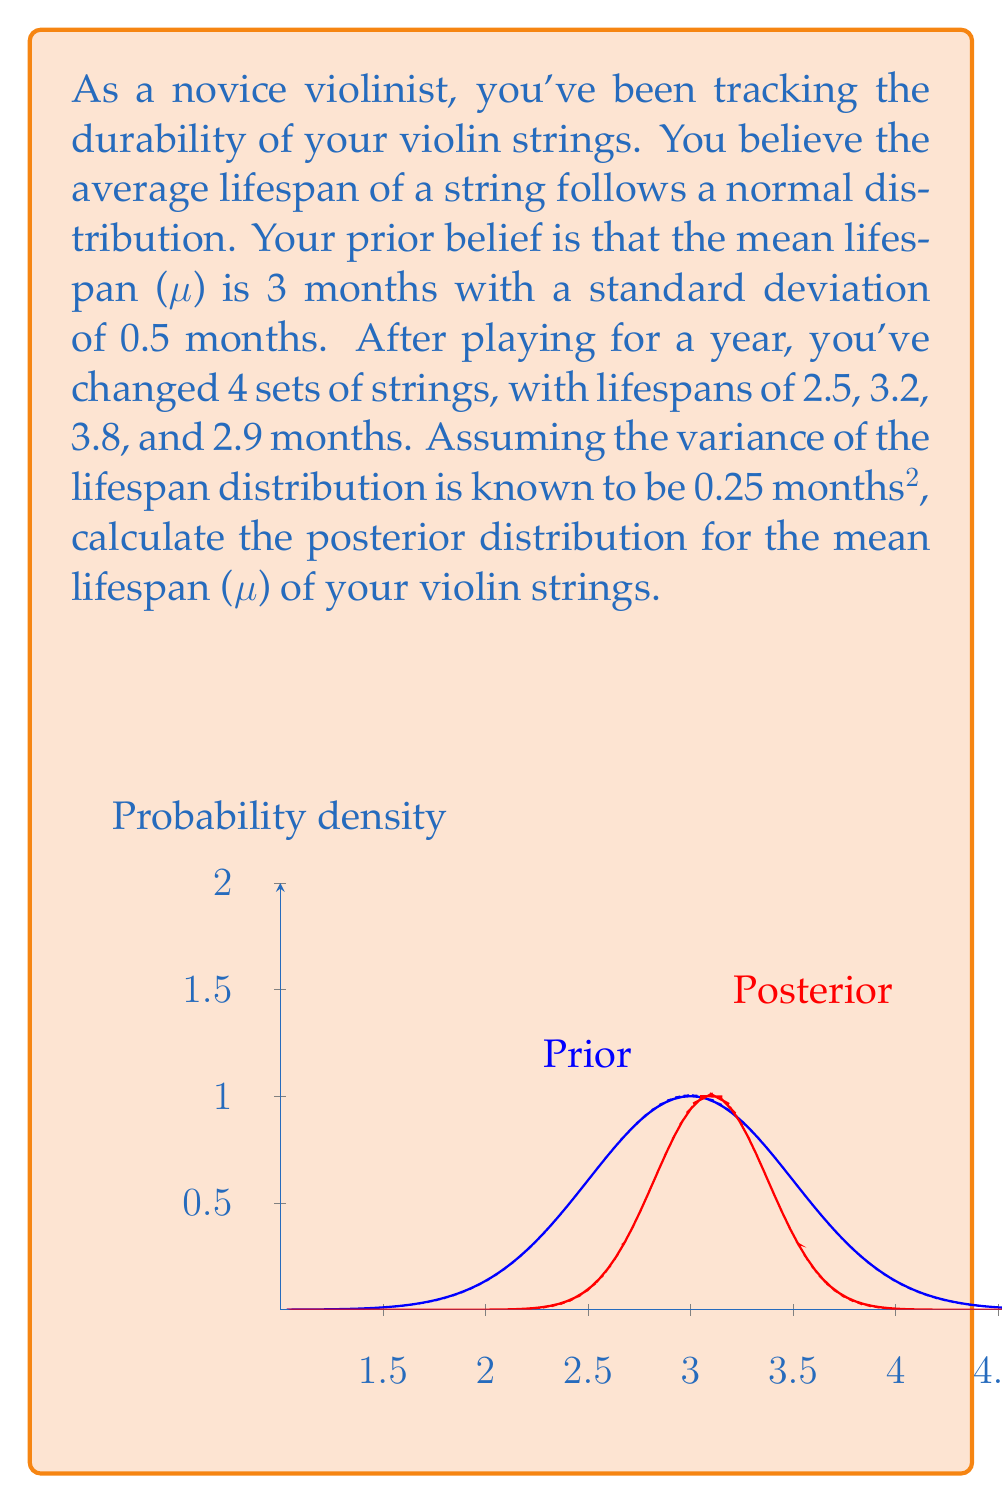Can you solve this math problem? Let's approach this step-by-step using Bayesian inference:

1) Prior distribution:
   $\mu \sim N(3, 0.5^2)$

2) Likelihood:
   The likelihood is based on our observed data. With 4 observations and known variance:
   $X_i \sim N(\mu, 0.25)$

3) Posterior distribution:
   For a normal prior and normal likelihood with known variance, the posterior is also normal.

4) Posterior parameters:
   Let $\tau_0 = \frac{1}{0.5^2} = 4$ (precision of prior)
   Let $\tau = \frac{1}{0.25} = 4$ (precision of likelihood)
   
   $n = 4$ (number of observations)
   $\bar{x} = \frac{2.5 + 3.2 + 3.8 + 2.9}{4} = 3.1$ (sample mean)

   Posterior precision: $\tau_n = \tau_0 + n\tau = 4 + 4(4) = 20$
   
   Posterior mean: $\mu_n = \frac{\tau_0\mu_0 + n\tau\bar{x}}{\tau_n} = \frac{4(3) + 4(4)(3.1)}{20} = 3.1$

   Posterior variance: $\sigma_n^2 = \frac{1}{\tau_n} = \frac{1}{20} = 0.05$

5) Therefore, the posterior distribution is:
   $\mu|x \sim N(3.1, 0.05)$

The graph shows the prior (blue) and posterior (red) distributions.
Answer: $\mu|x \sim N(3.1, 0.05)$ 